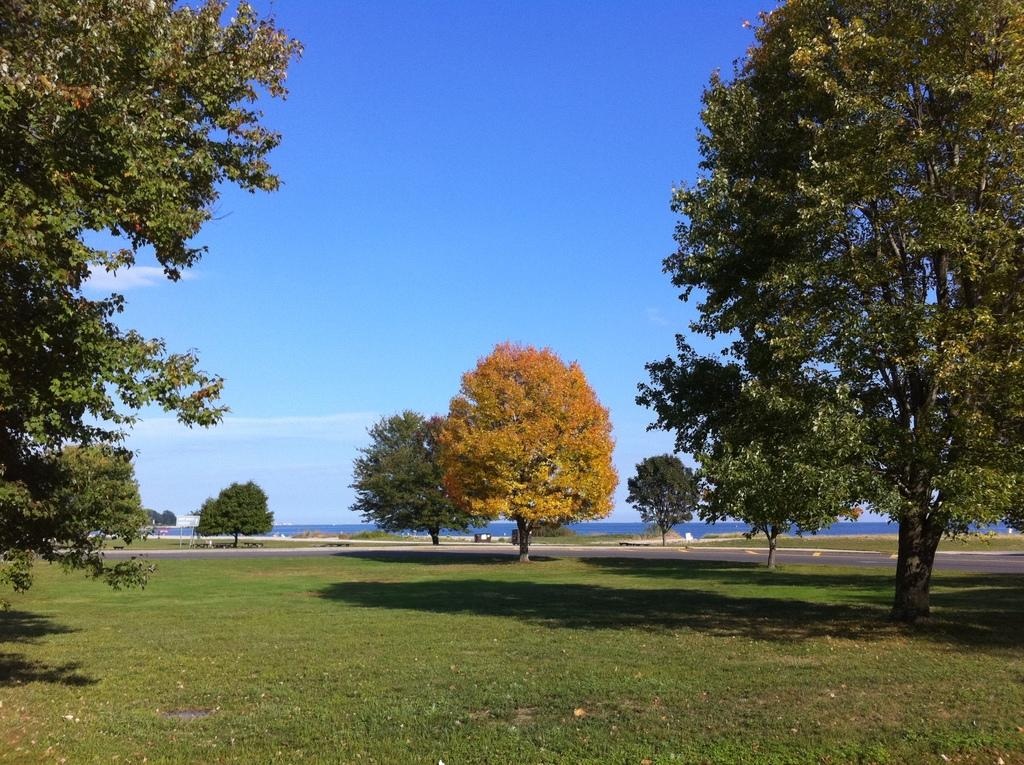What type of vegetation can be seen in the image? There are trees and grass visible in the image. What can be seen in the background of the image? In the background of the image, there is water, plants, boards, a road, and other objects. What part of the natural environment is visible in the image? The sky is visible in the background of the image. What degree does the goat have in the image? There is no goat present in the image. What date is shown on the calendar in the image? There is no calendar present in the image. 